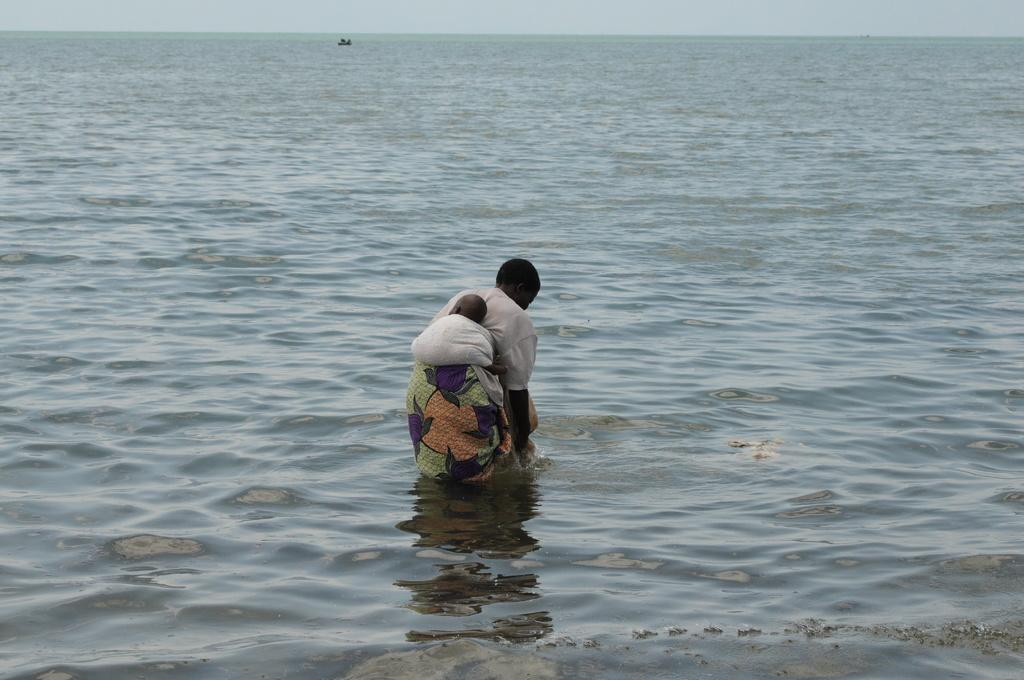What is at the bottom of the image? There is water at the bottom of the image. What is happening in the water? A woman is in the water, holding a baby tied with a cloth to her. What can be seen in the background of the image? There is a boat and the sky visible in the background of the image. What type of cap is the baby wearing in the image? There is no cap visible on the baby in the image. On which side of the woman is the baby tied in the image? The baby is tied to the woman's front, not her side, in the image. 